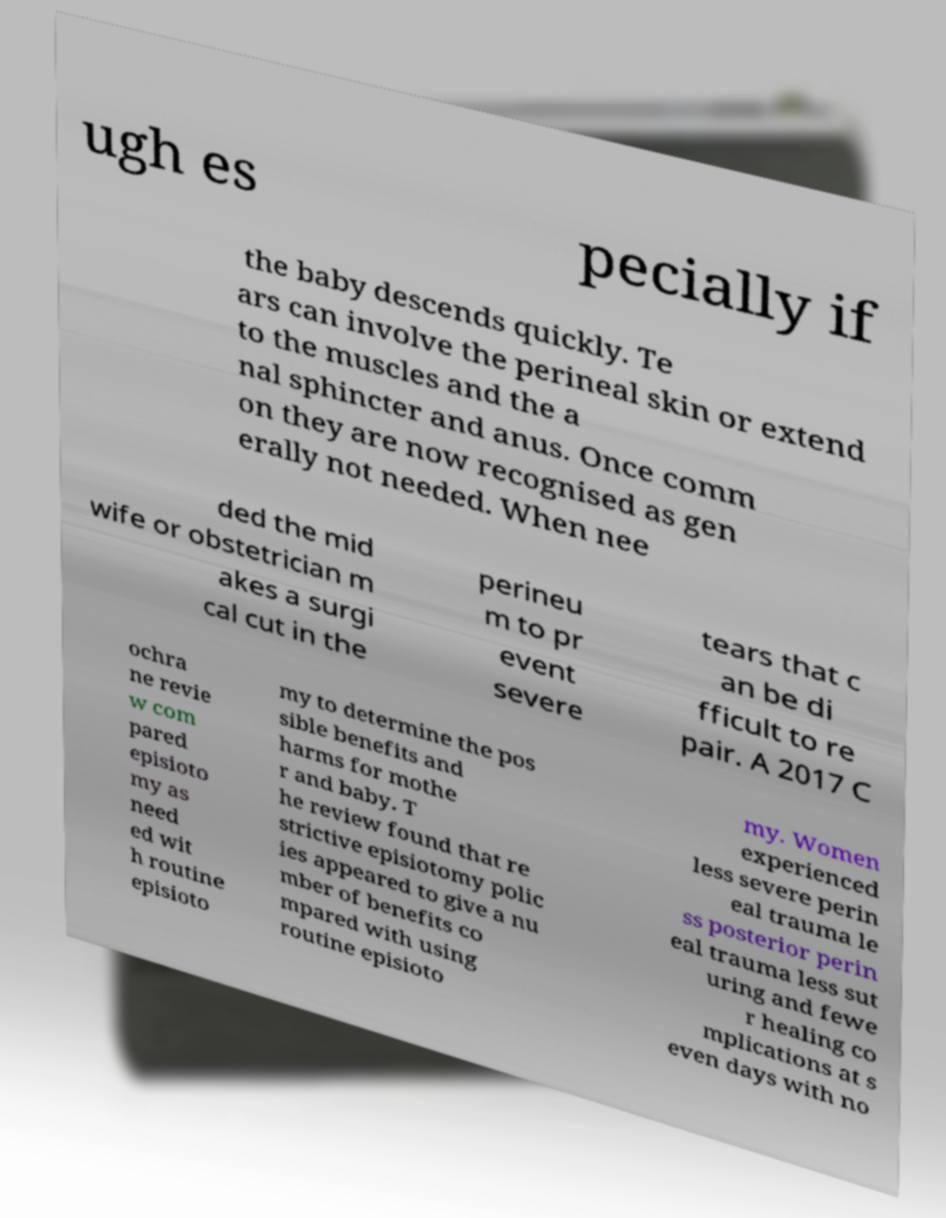For documentation purposes, I need the text within this image transcribed. Could you provide that? ugh es pecially if the baby descends quickly. Te ars can involve the perineal skin or extend to the muscles and the a nal sphincter and anus. Once comm on they are now recognised as gen erally not needed. When nee ded the mid wife or obstetrician m akes a surgi cal cut in the perineu m to pr event severe tears that c an be di fficult to re pair. A 2017 C ochra ne revie w com pared episioto my as need ed wit h routine episioto my to determine the pos sible benefits and harms for mothe r and baby. T he review found that re strictive episiotomy polic ies appeared to give a nu mber of benefits co mpared with using routine episioto my. Women experienced less severe perin eal trauma le ss posterior perin eal trauma less sut uring and fewe r healing co mplications at s even days with no 